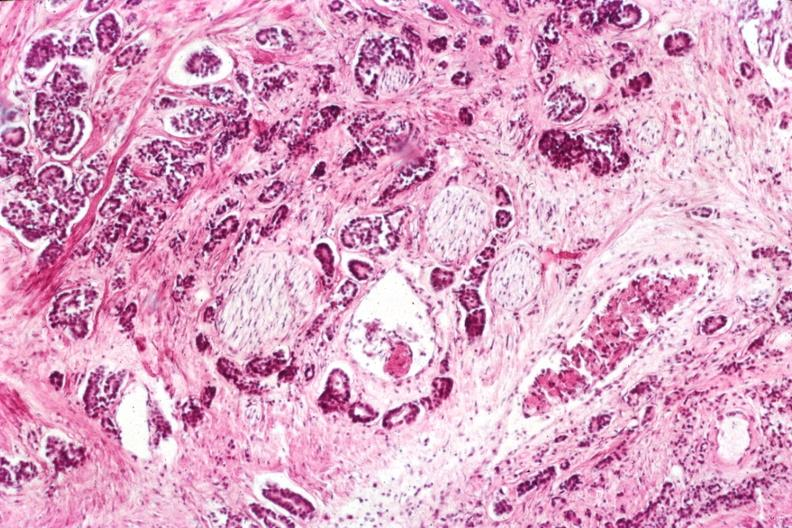does this image show very nice view of infiltrating neoplasm with perineural invasion typical prostate lesion?
Answer the question using a single word or phrase. Yes 